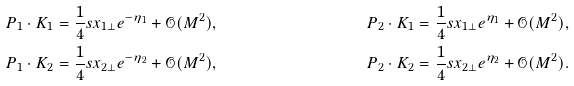Convert formula to latex. <formula><loc_0><loc_0><loc_500><loc_500>P _ { 1 } \cdot K _ { 1 } & = \frac { 1 } { 4 } s x _ { 1 \perp } e ^ { - \eta _ { 1 } } + \mathcal { O } ( M ^ { 2 } ) , & P _ { 2 } \cdot K _ { 1 } & = \frac { 1 } { 4 } s x _ { 1 \perp } e ^ { \eta _ { 1 } } + \mathcal { O } ( M ^ { 2 } ) , \\ P _ { 1 } \cdot K _ { 2 } & = \frac { 1 } { 4 } s x _ { 2 \perp } e ^ { - \eta _ { 2 } } + \mathcal { O } ( M ^ { 2 } ) , & P _ { 2 } \cdot K _ { 2 } & = \frac { 1 } { 4 } s x _ { 2 \perp } e ^ { \eta _ { 2 } } + \mathcal { O } ( M ^ { 2 } ) .</formula> 